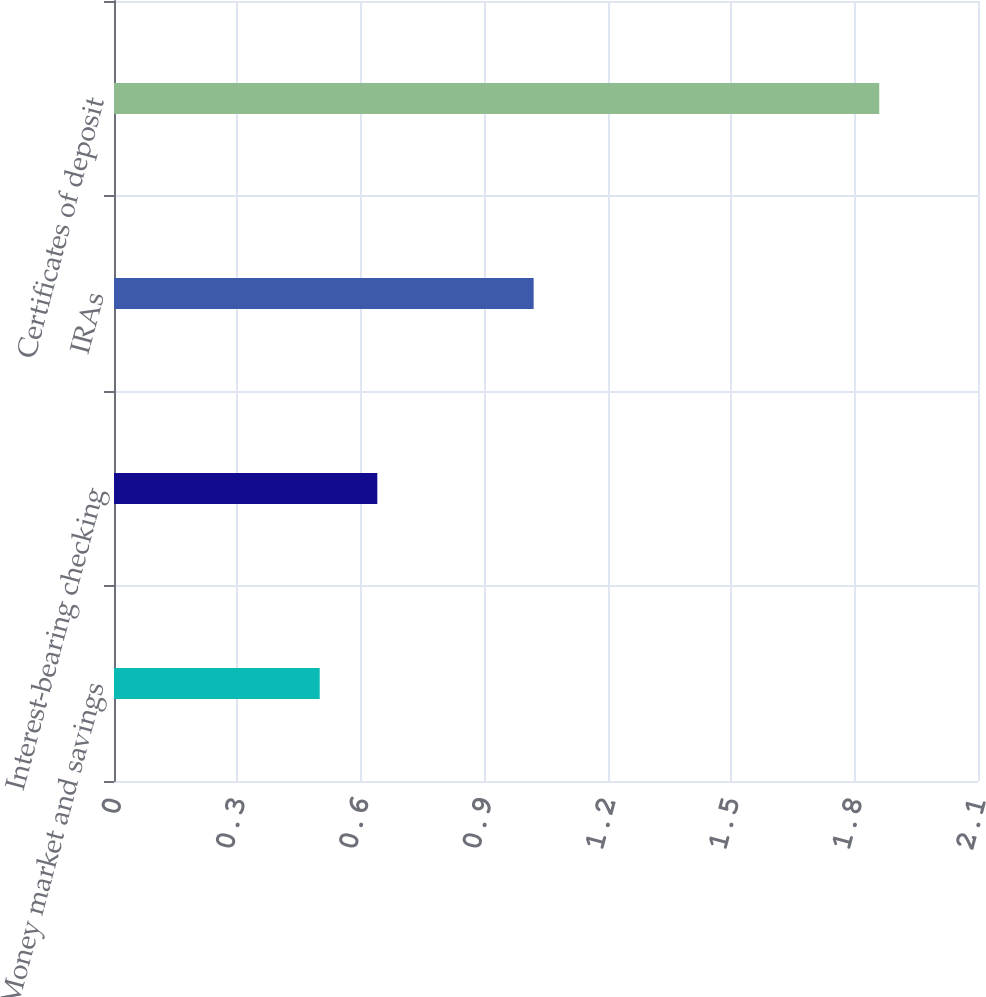<chart> <loc_0><loc_0><loc_500><loc_500><bar_chart><fcel>Money market and savings<fcel>Interest-bearing checking<fcel>IRAs<fcel>Certificates of deposit<nl><fcel>0.5<fcel>0.64<fcel>1.02<fcel>1.86<nl></chart> 